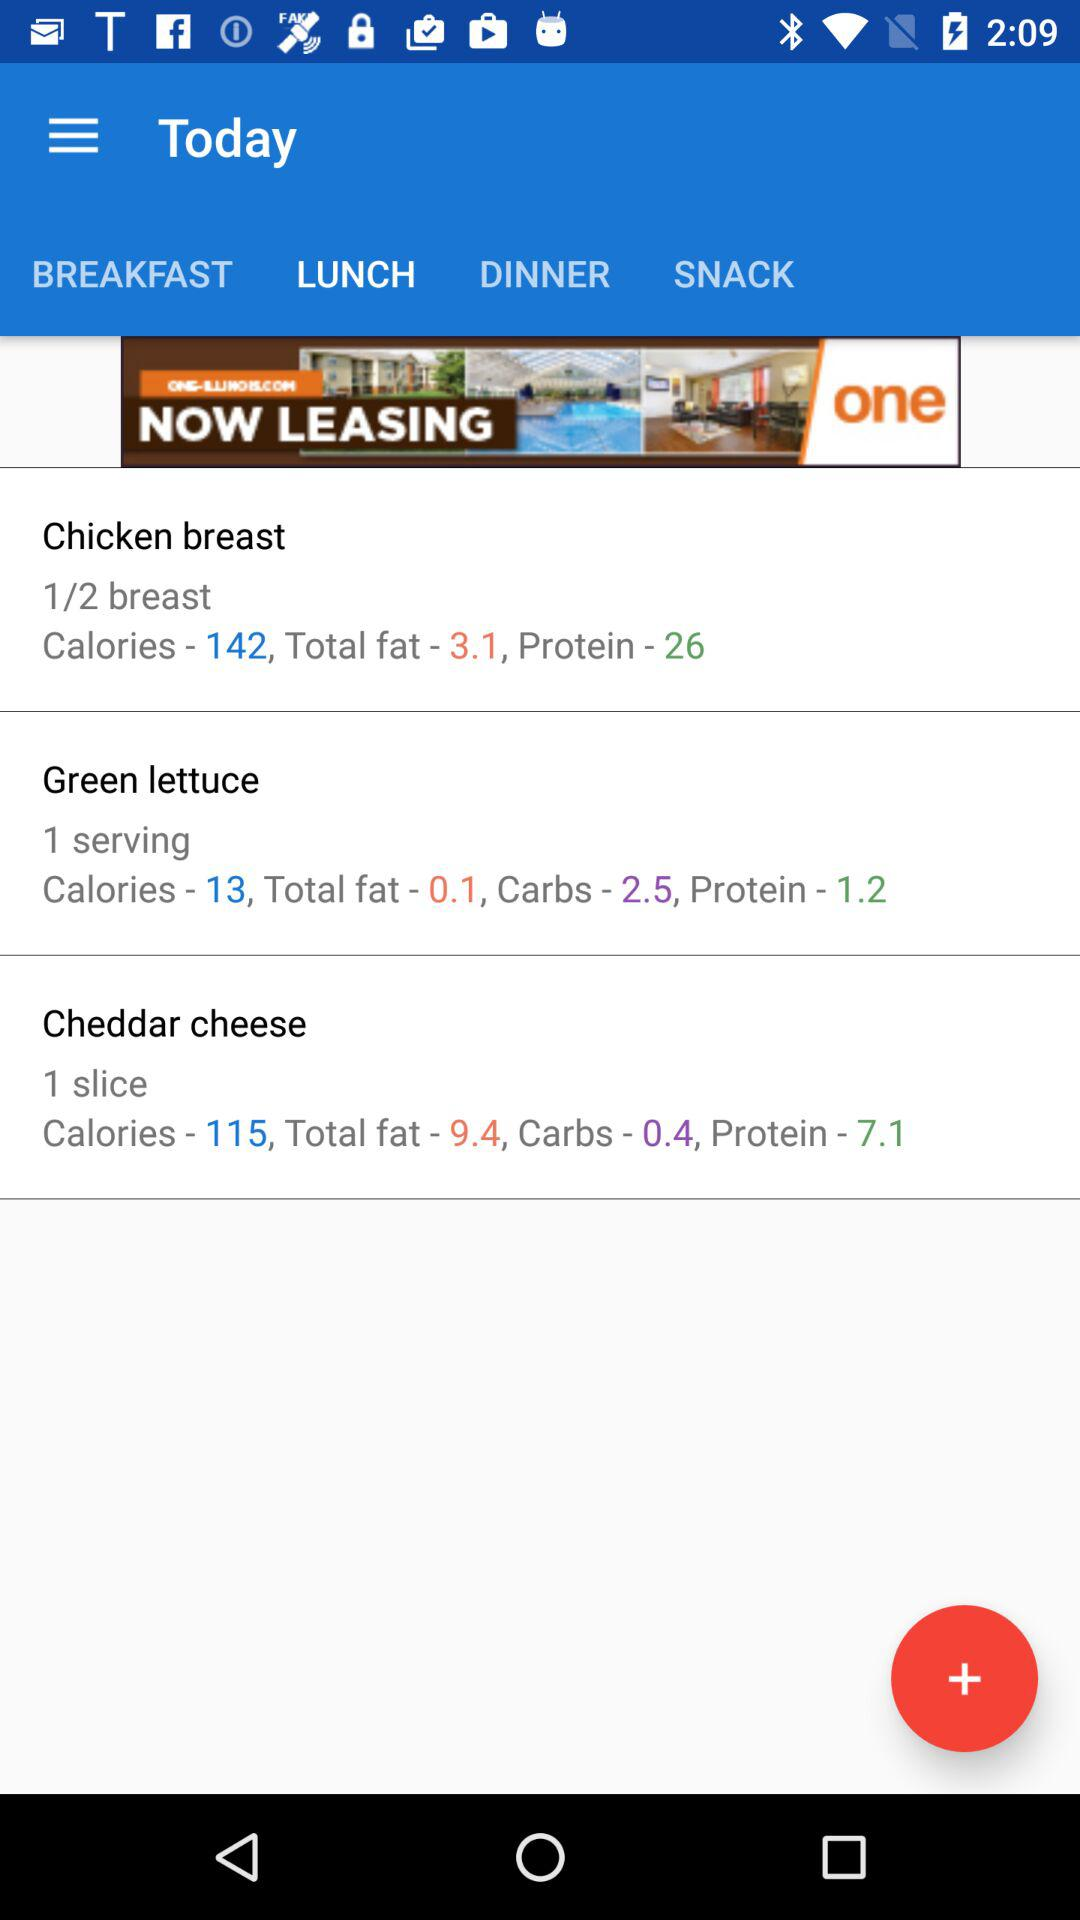How many calories are in "Green lettuce"? There are 13 calories in "Green lettuce". 